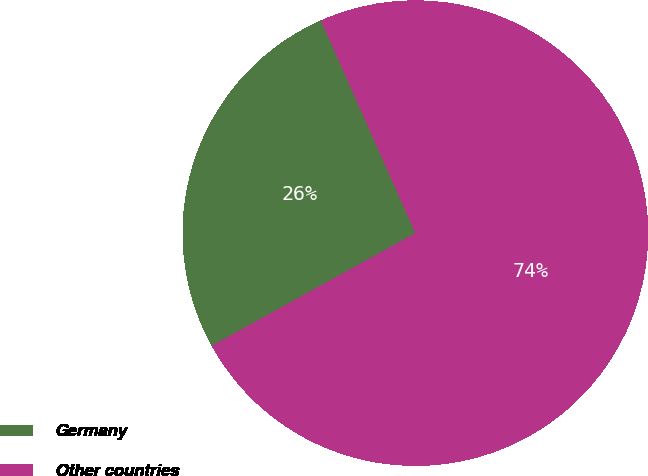Convert chart. <chart><loc_0><loc_0><loc_500><loc_500><pie_chart><fcel>Germany<fcel>Other countries<nl><fcel>26.4%<fcel>73.6%<nl></chart> 